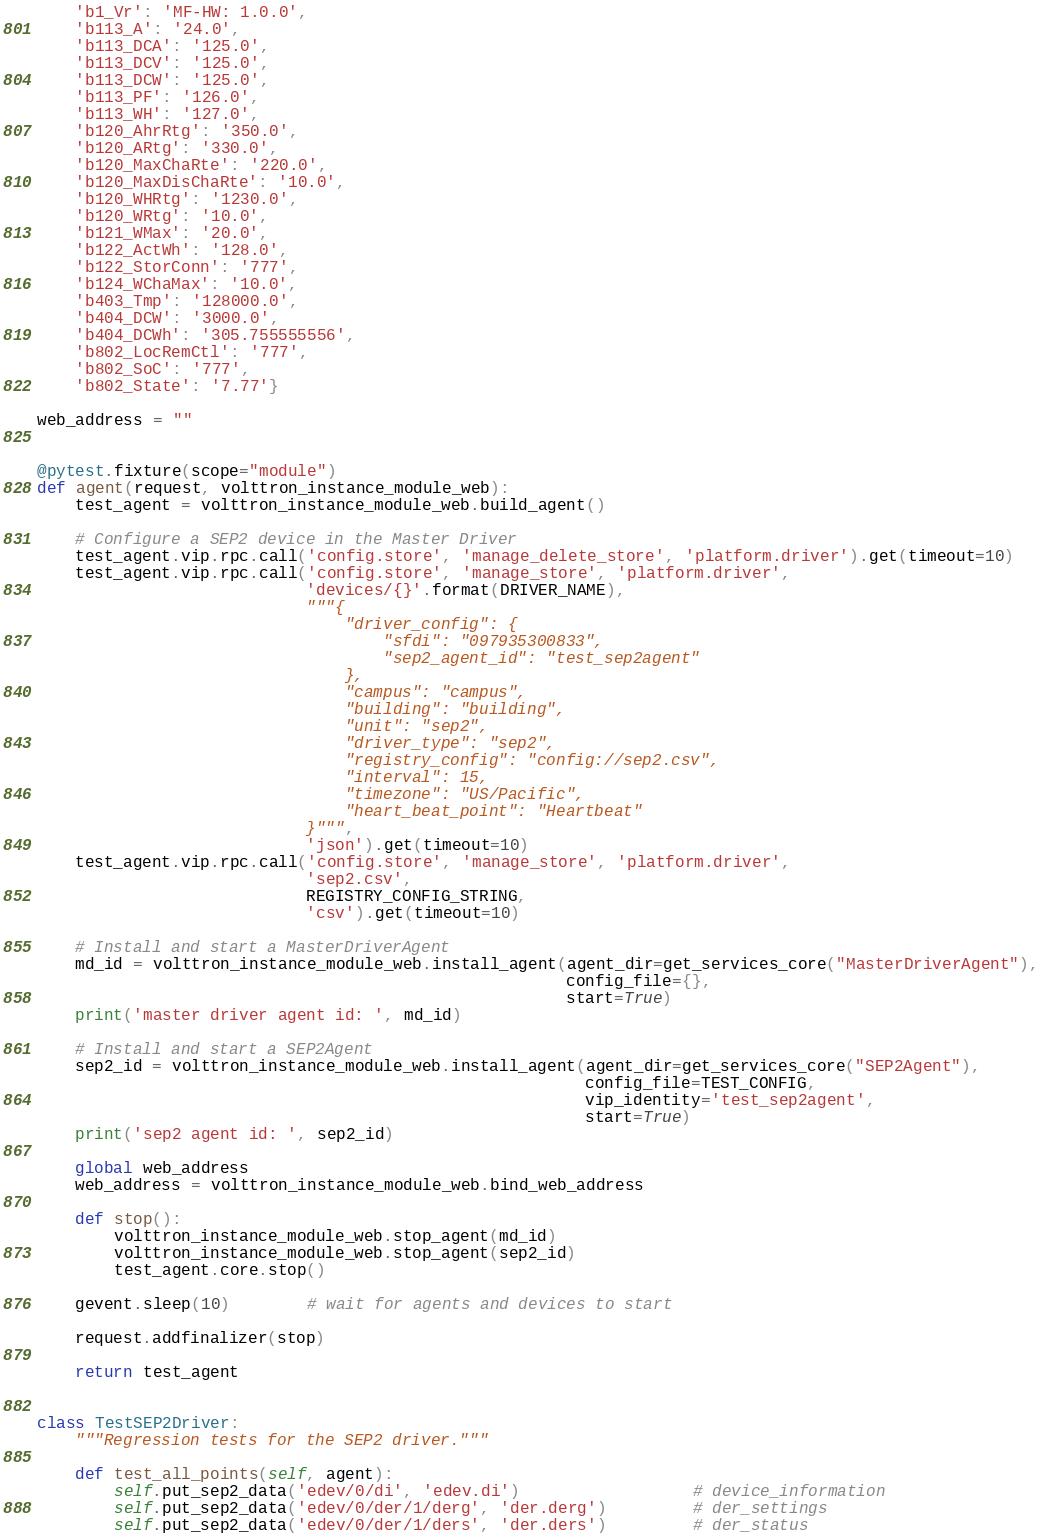Convert code to text. <code><loc_0><loc_0><loc_500><loc_500><_Python_>    'b1_Vr': 'MF-HW: 1.0.0',
    'b113_A': '24.0',
    'b113_DCA': '125.0',
    'b113_DCV': '125.0',
    'b113_DCW': '125.0',
    'b113_PF': '126.0',
    'b113_WH': '127.0',
    'b120_AhrRtg': '350.0',
    'b120_ARtg': '330.0',
    'b120_MaxChaRte': '220.0',
    'b120_MaxDisChaRte': '10.0',
    'b120_WHRtg': '1230.0',
    'b120_WRtg': '10.0',
    'b121_WMax': '20.0',
    'b122_ActWh': '128.0',
    'b122_StorConn': '777',
    'b124_WChaMax': '10.0',
    'b403_Tmp': '128000.0',
    'b404_DCW': '3000.0',
    'b404_DCWh': '305.755555556',
    'b802_LocRemCtl': '777',
    'b802_SoC': '777',
    'b802_State': '7.77'}

web_address = ""


@pytest.fixture(scope="module")
def agent(request, volttron_instance_module_web):
    test_agent = volttron_instance_module_web.build_agent()

    # Configure a SEP2 device in the Master Driver
    test_agent.vip.rpc.call('config.store', 'manage_delete_store', 'platform.driver').get(timeout=10)
    test_agent.vip.rpc.call('config.store', 'manage_store', 'platform.driver',
                            'devices/{}'.format(DRIVER_NAME),
                            """{
                                "driver_config": {
                                    "sfdi": "097935300833",
                                    "sep2_agent_id": "test_sep2agent"
                                },
                                "campus": "campus",
                                "building": "building",
                                "unit": "sep2",
                                "driver_type": "sep2",
                                "registry_config": "config://sep2.csv",
                                "interval": 15,
                                "timezone": "US/Pacific",
                                "heart_beat_point": "Heartbeat"
                            }""",
                            'json').get(timeout=10)
    test_agent.vip.rpc.call('config.store', 'manage_store', 'platform.driver',
                            'sep2.csv',
                            REGISTRY_CONFIG_STRING,
                            'csv').get(timeout=10)

    # Install and start a MasterDriverAgent
    md_id = volttron_instance_module_web.install_agent(agent_dir=get_services_core("MasterDriverAgent"),
                                                       config_file={},
                                                       start=True)
    print('master driver agent id: ', md_id)

    # Install and start a SEP2Agent
    sep2_id = volttron_instance_module_web.install_agent(agent_dir=get_services_core("SEP2Agent"),
                                                         config_file=TEST_CONFIG,
                                                         vip_identity='test_sep2agent',
                                                         start=True)
    print('sep2 agent id: ', sep2_id)

    global web_address
    web_address = volttron_instance_module_web.bind_web_address

    def stop():
        volttron_instance_module_web.stop_agent(md_id)
        volttron_instance_module_web.stop_agent(sep2_id)
        test_agent.core.stop()

    gevent.sleep(10)        # wait for agents and devices to start

    request.addfinalizer(stop)

    return test_agent


class TestSEP2Driver:
    """Regression tests for the SEP2 driver."""

    def test_all_points(self, agent):
        self.put_sep2_data('edev/0/di', 'edev.di')                  # device_information
        self.put_sep2_data('edev/0/der/1/derg', 'der.derg')         # der_settings
        self.put_sep2_data('edev/0/der/1/ders', 'der.ders')         # der_status</code> 